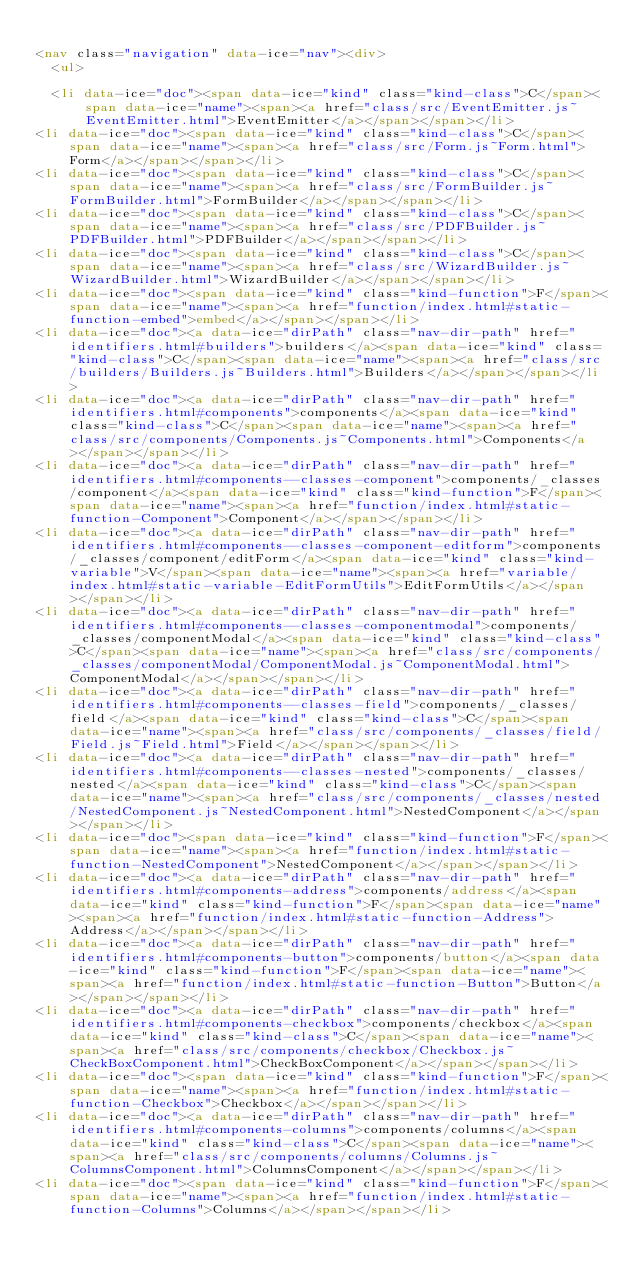<code> <loc_0><loc_0><loc_500><loc_500><_HTML_>
<nav class="navigation" data-ice="nav"><div>
  <ul>
    
  <li data-ice="doc"><span data-ice="kind" class="kind-class">C</span><span data-ice="name"><span><a href="class/src/EventEmitter.js~EventEmitter.html">EventEmitter</a></span></span></li>
<li data-ice="doc"><span data-ice="kind" class="kind-class">C</span><span data-ice="name"><span><a href="class/src/Form.js~Form.html">Form</a></span></span></li>
<li data-ice="doc"><span data-ice="kind" class="kind-class">C</span><span data-ice="name"><span><a href="class/src/FormBuilder.js~FormBuilder.html">FormBuilder</a></span></span></li>
<li data-ice="doc"><span data-ice="kind" class="kind-class">C</span><span data-ice="name"><span><a href="class/src/PDFBuilder.js~PDFBuilder.html">PDFBuilder</a></span></span></li>
<li data-ice="doc"><span data-ice="kind" class="kind-class">C</span><span data-ice="name"><span><a href="class/src/WizardBuilder.js~WizardBuilder.html">WizardBuilder</a></span></span></li>
<li data-ice="doc"><span data-ice="kind" class="kind-function">F</span><span data-ice="name"><span><a href="function/index.html#static-function-embed">embed</a></span></span></li>
<li data-ice="doc"><a data-ice="dirPath" class="nav-dir-path" href="identifiers.html#builders">builders</a><span data-ice="kind" class="kind-class">C</span><span data-ice="name"><span><a href="class/src/builders/Builders.js~Builders.html">Builders</a></span></span></li>
<li data-ice="doc"><a data-ice="dirPath" class="nav-dir-path" href="identifiers.html#components">components</a><span data-ice="kind" class="kind-class">C</span><span data-ice="name"><span><a href="class/src/components/Components.js~Components.html">Components</a></span></span></li>
<li data-ice="doc"><a data-ice="dirPath" class="nav-dir-path" href="identifiers.html#components--classes-component">components/_classes/component</a><span data-ice="kind" class="kind-function">F</span><span data-ice="name"><span><a href="function/index.html#static-function-Component">Component</a></span></span></li>
<li data-ice="doc"><a data-ice="dirPath" class="nav-dir-path" href="identifiers.html#components--classes-component-editform">components/_classes/component/editForm</a><span data-ice="kind" class="kind-variable">V</span><span data-ice="name"><span><a href="variable/index.html#static-variable-EditFormUtils">EditFormUtils</a></span></span></li>
<li data-ice="doc"><a data-ice="dirPath" class="nav-dir-path" href="identifiers.html#components--classes-componentmodal">components/_classes/componentModal</a><span data-ice="kind" class="kind-class">C</span><span data-ice="name"><span><a href="class/src/components/_classes/componentModal/ComponentModal.js~ComponentModal.html">ComponentModal</a></span></span></li>
<li data-ice="doc"><a data-ice="dirPath" class="nav-dir-path" href="identifiers.html#components--classes-field">components/_classes/field</a><span data-ice="kind" class="kind-class">C</span><span data-ice="name"><span><a href="class/src/components/_classes/field/Field.js~Field.html">Field</a></span></span></li>
<li data-ice="doc"><a data-ice="dirPath" class="nav-dir-path" href="identifiers.html#components--classes-nested">components/_classes/nested</a><span data-ice="kind" class="kind-class">C</span><span data-ice="name"><span><a href="class/src/components/_classes/nested/NestedComponent.js~NestedComponent.html">NestedComponent</a></span></span></li>
<li data-ice="doc"><span data-ice="kind" class="kind-function">F</span><span data-ice="name"><span><a href="function/index.html#static-function-NestedComponent">NestedComponent</a></span></span></li>
<li data-ice="doc"><a data-ice="dirPath" class="nav-dir-path" href="identifiers.html#components-address">components/address</a><span data-ice="kind" class="kind-function">F</span><span data-ice="name"><span><a href="function/index.html#static-function-Address">Address</a></span></span></li>
<li data-ice="doc"><a data-ice="dirPath" class="nav-dir-path" href="identifiers.html#components-button">components/button</a><span data-ice="kind" class="kind-function">F</span><span data-ice="name"><span><a href="function/index.html#static-function-Button">Button</a></span></span></li>
<li data-ice="doc"><a data-ice="dirPath" class="nav-dir-path" href="identifiers.html#components-checkbox">components/checkbox</a><span data-ice="kind" class="kind-class">C</span><span data-ice="name"><span><a href="class/src/components/checkbox/Checkbox.js~CheckBoxComponent.html">CheckBoxComponent</a></span></span></li>
<li data-ice="doc"><span data-ice="kind" class="kind-function">F</span><span data-ice="name"><span><a href="function/index.html#static-function-Checkbox">Checkbox</a></span></span></li>
<li data-ice="doc"><a data-ice="dirPath" class="nav-dir-path" href="identifiers.html#components-columns">components/columns</a><span data-ice="kind" class="kind-class">C</span><span data-ice="name"><span><a href="class/src/components/columns/Columns.js~ColumnsComponent.html">ColumnsComponent</a></span></span></li>
<li data-ice="doc"><span data-ice="kind" class="kind-function">F</span><span data-ice="name"><span><a href="function/index.html#static-function-Columns">Columns</a></span></span></li></code> 